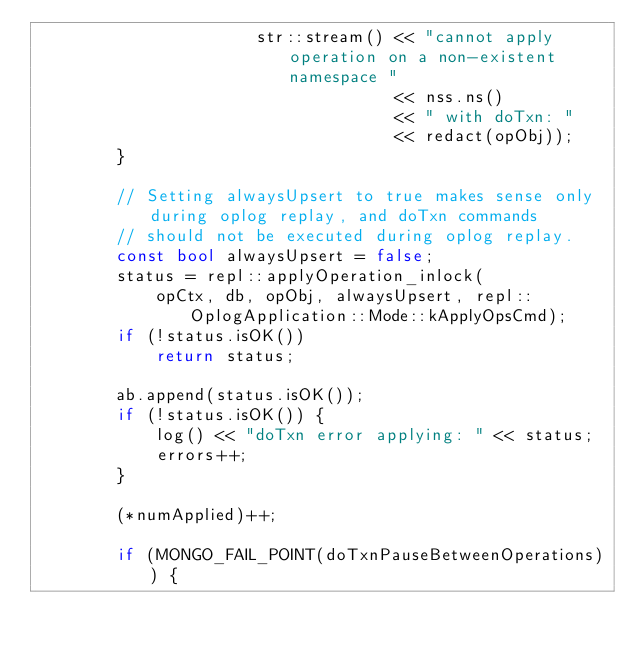Convert code to text. <code><loc_0><loc_0><loc_500><loc_500><_C++_>                      str::stream() << "cannot apply operation on a non-existent namespace "
                                    << nss.ns()
                                    << " with doTxn: "
                                    << redact(opObj));
        }

        // Setting alwaysUpsert to true makes sense only during oplog replay, and doTxn commands
        // should not be executed during oplog replay.
        const bool alwaysUpsert = false;
        status = repl::applyOperation_inlock(
            opCtx, db, opObj, alwaysUpsert, repl::OplogApplication::Mode::kApplyOpsCmd);
        if (!status.isOK())
            return status;

        ab.append(status.isOK());
        if (!status.isOK()) {
            log() << "doTxn error applying: " << status;
            errors++;
        }

        (*numApplied)++;

        if (MONGO_FAIL_POINT(doTxnPauseBetweenOperations)) {</code> 